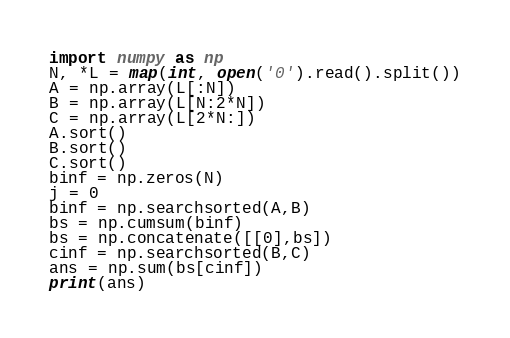<code> <loc_0><loc_0><loc_500><loc_500><_Python_>import numpy as np
N, *L = map(int, open('0').read().split())
A = np.array(L[:N])
B = np.array(L[N:2*N])
C = np.array(L[2*N:])
A.sort()
B.sort()
C.sort()
binf = np.zeros(N)
j = 0
binf = np.searchsorted(A,B)
bs = np.cumsum(binf)
bs = np.concatenate([[0],bs])
cinf = np.searchsorted(B,C)
ans = np.sum(bs[cinf])
print(ans)</code> 